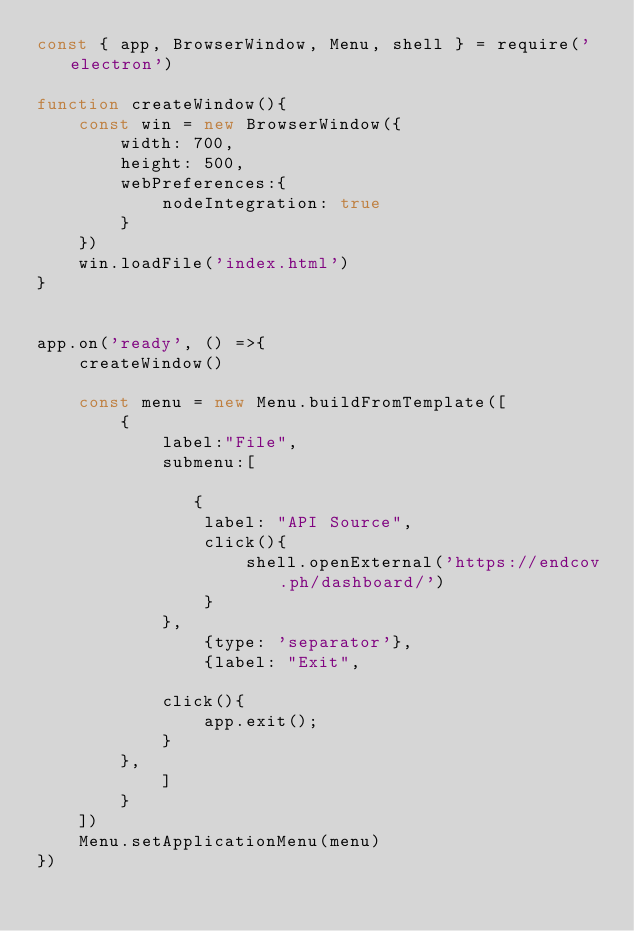Convert code to text. <code><loc_0><loc_0><loc_500><loc_500><_JavaScript_>const { app, BrowserWindow, Menu, shell } = require('electron')

function createWindow(){
    const win = new BrowserWindow({
        width: 700,
        height: 500,
        webPreferences:{
            nodeIntegration: true
        }
    })
    win.loadFile('index.html')
}


app.on('ready', () =>{
    createWindow()

    const menu = new Menu.buildFromTemplate([
        {
            label:"File",
            submenu:[

               {
                label: "API Source",
                click(){
                    shell.openExternal('https://endcov.ph/dashboard/')
                }
            },
                {type: 'separator'},
                {label: "Exit",
              
            click(){
                app.exit();
            }
        },
            ]
        }
    ])
    Menu.setApplicationMenu(menu)
})

</code> 